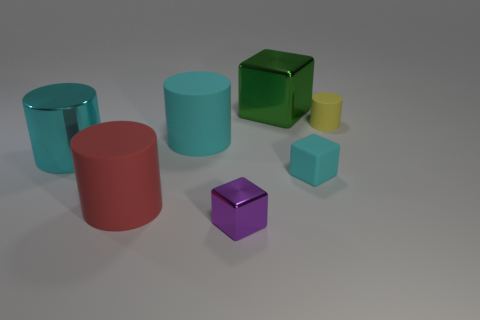Add 1 large matte cylinders. How many objects exist? 8 Subtract all cylinders. How many objects are left? 3 Add 3 big red matte things. How many big red matte things are left? 4 Add 2 tiny red shiny objects. How many tiny red shiny objects exist? 2 Subtract 0 brown blocks. How many objects are left? 7 Subtract all large red metal blocks. Subtract all large red matte cylinders. How many objects are left? 6 